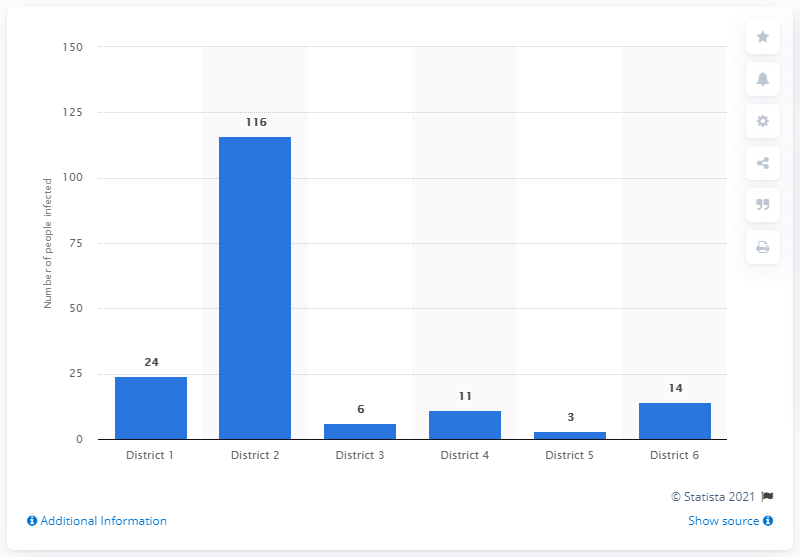Highlight a few significant elements in this photo. As of February 12, 2023, a total of 116 individuals have been infected with the coronavirus. 